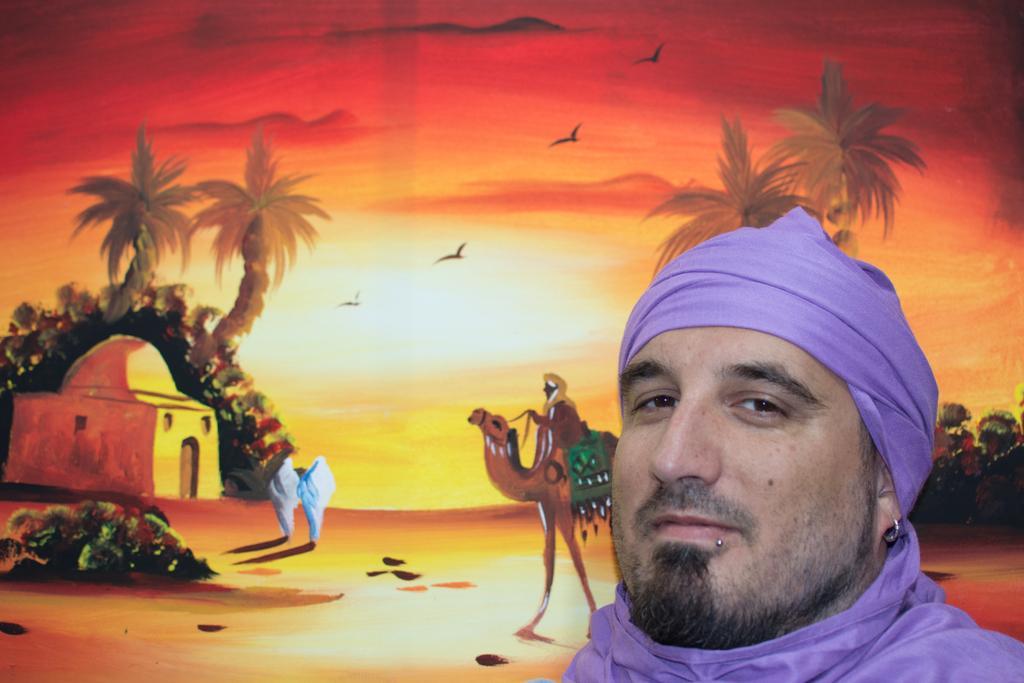Describe this image in one or two sentences. In this picture I can see a man, there is a painting, in which there is a person riding a camel, there is a house, there are trees, there are birds flying, and in the background there is the sky. 